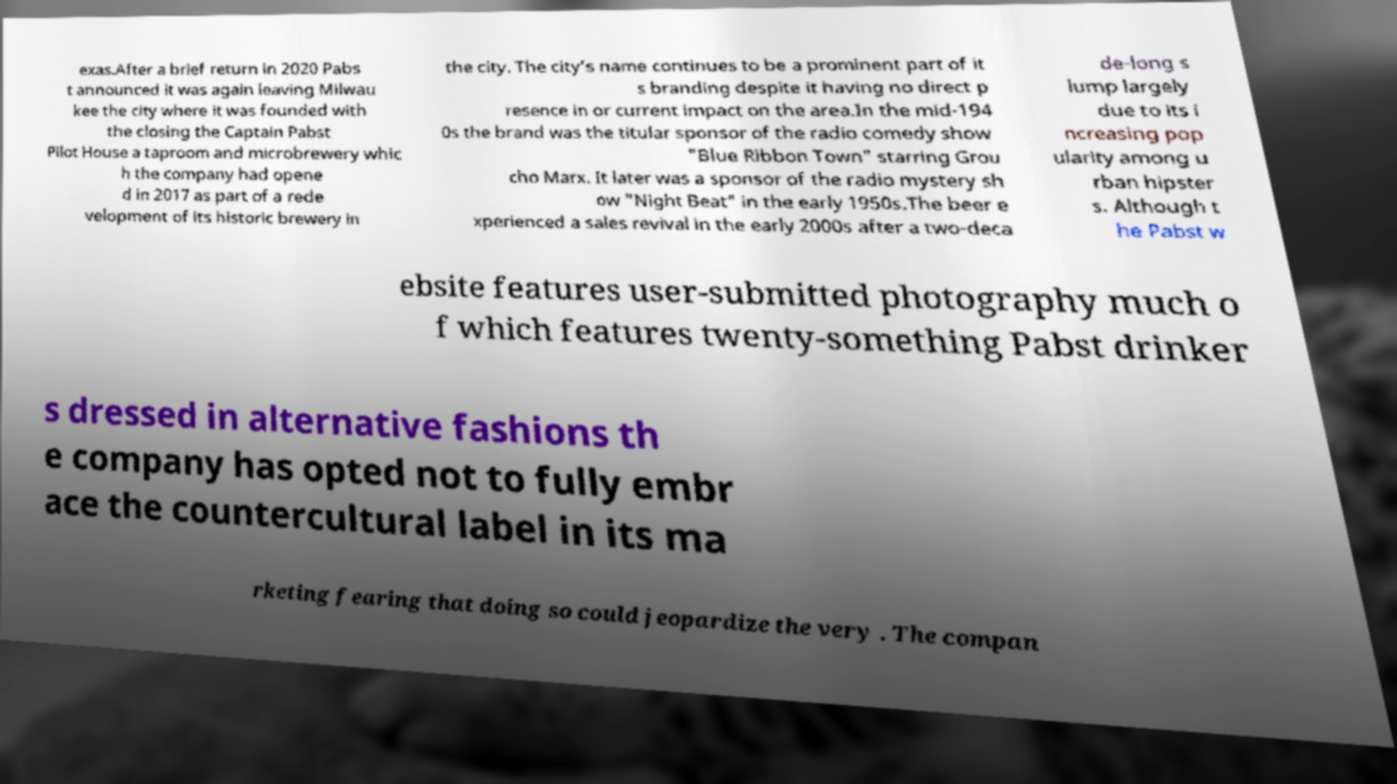For documentation purposes, I need the text within this image transcribed. Could you provide that? exas.After a brief return in 2020 Pabs t announced it was again leaving Milwau kee the city where it was founded with the closing the Captain Pabst Pilot House a taproom and microbrewery whic h the company had opene d in 2017 as part of a rede velopment of its historic brewery in the city. The city’s name continues to be a prominent part of it s branding despite it having no direct p resence in or current impact on the area.In the mid-194 0s the brand was the titular sponsor of the radio comedy show "Blue Ribbon Town" starring Grou cho Marx. It later was a sponsor of the radio mystery sh ow "Night Beat" in the early 1950s.The beer e xperienced a sales revival in the early 2000s after a two-deca de-long s lump largely due to its i ncreasing pop ularity among u rban hipster s. Although t he Pabst w ebsite features user-submitted photography much o f which features twenty-something Pabst drinker s dressed in alternative fashions th e company has opted not to fully embr ace the countercultural label in its ma rketing fearing that doing so could jeopardize the very . The compan 